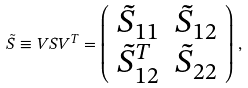<formula> <loc_0><loc_0><loc_500><loc_500>\tilde { S } \equiv V S V ^ { T } = \left ( \begin{array} { c c } \tilde { S } _ { 1 1 } & \tilde { S } _ { 1 2 } \\ \tilde { S } _ { 1 2 } ^ { T } & \tilde { S } _ { 2 2 } \end{array} \right ) \, ,</formula> 